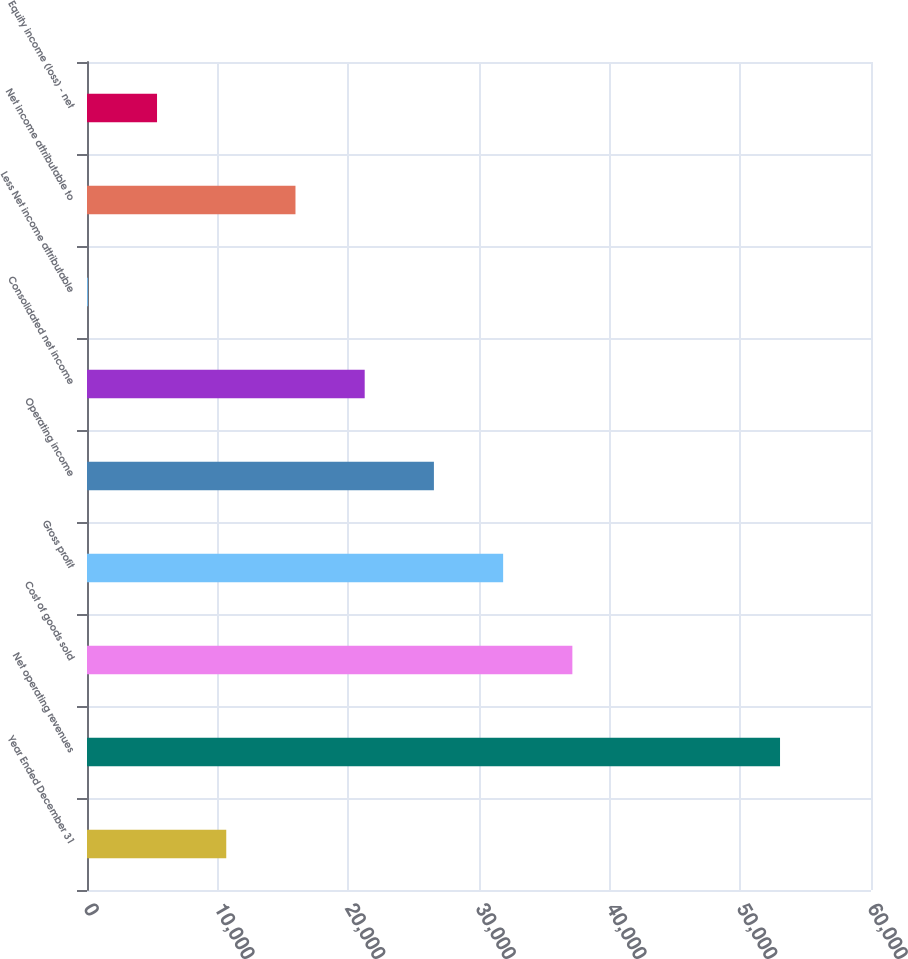Convert chart to OTSL. <chart><loc_0><loc_0><loc_500><loc_500><bar_chart><fcel>Year Ended December 31<fcel>Net operating revenues<fcel>Cost of goods sold<fcel>Gross profit<fcel>Operating income<fcel>Consolidated net income<fcel>Less Net income attributable<fcel>Net income attributable to<fcel>Equity income (loss) - net<nl><fcel>10657.2<fcel>53038<fcel>37145.2<fcel>31847.6<fcel>26550<fcel>21252.4<fcel>62<fcel>15954.8<fcel>5359.6<nl></chart> 